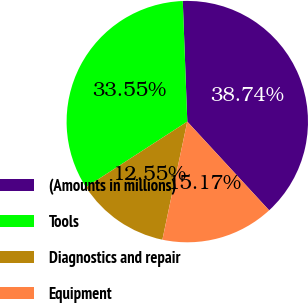Convert chart to OTSL. <chart><loc_0><loc_0><loc_500><loc_500><pie_chart><fcel>(Amounts in millions)<fcel>Tools<fcel>Diagnostics and repair<fcel>Equipment<nl><fcel>38.74%<fcel>33.55%<fcel>12.55%<fcel>15.17%<nl></chart> 